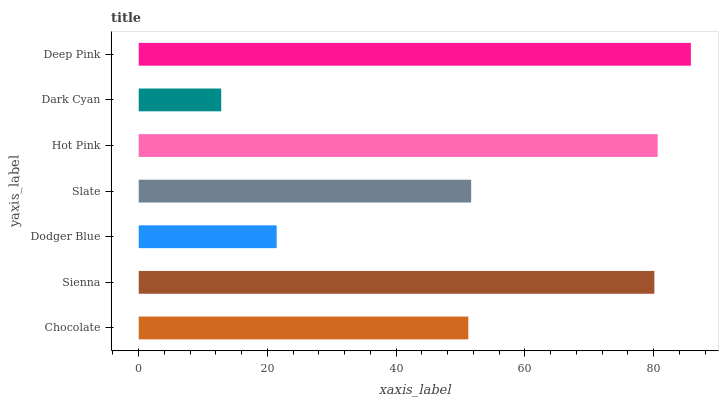Is Dark Cyan the minimum?
Answer yes or no. Yes. Is Deep Pink the maximum?
Answer yes or no. Yes. Is Sienna the minimum?
Answer yes or no. No. Is Sienna the maximum?
Answer yes or no. No. Is Sienna greater than Chocolate?
Answer yes or no. Yes. Is Chocolate less than Sienna?
Answer yes or no. Yes. Is Chocolate greater than Sienna?
Answer yes or no. No. Is Sienna less than Chocolate?
Answer yes or no. No. Is Slate the high median?
Answer yes or no. Yes. Is Slate the low median?
Answer yes or no. Yes. Is Hot Pink the high median?
Answer yes or no. No. Is Dark Cyan the low median?
Answer yes or no. No. 